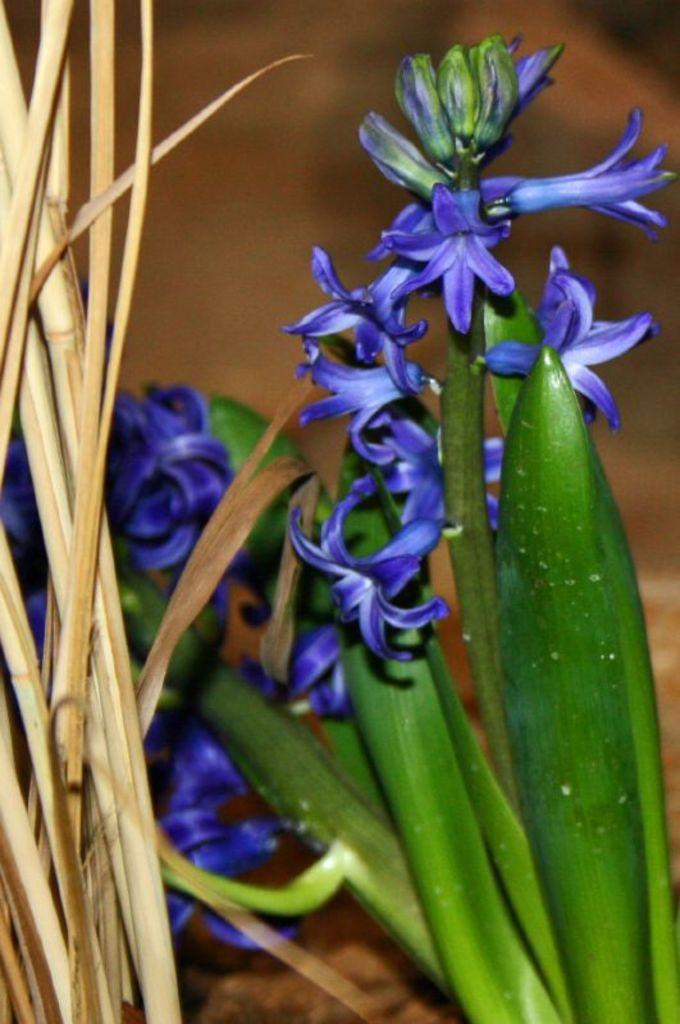What type of plants can be seen in the image? There are plants with violet color flowers in the image. Are there any plants with specific characteristics in the image? Yes, there are plants with dry leaves in the image. Can you describe the background of the image? The background of the image is blurred. What type of leather material can be seen on the bird in the image? There is no bird present in the image, and therefore no leather material can be observed. 